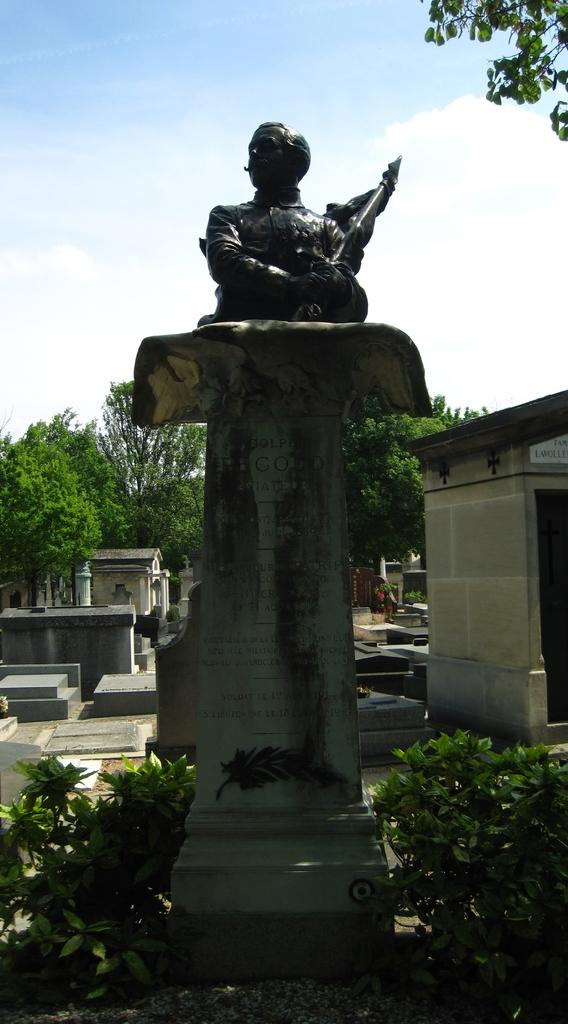What is the main subject in the image? There is a statue in the image. What is located near the statue? There are plants near the statue. What other objects can be seen in the image? There are stones, a shed, and trees in the image. What is visible in the background of the image? The sky with clouds is visible in the background of the image. How does the statue express its dislike for the plants in the image? The statue is an inanimate object and cannot express emotions like hate. 